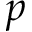Convert formula to latex. <formula><loc_0><loc_0><loc_500><loc_500>p</formula> 